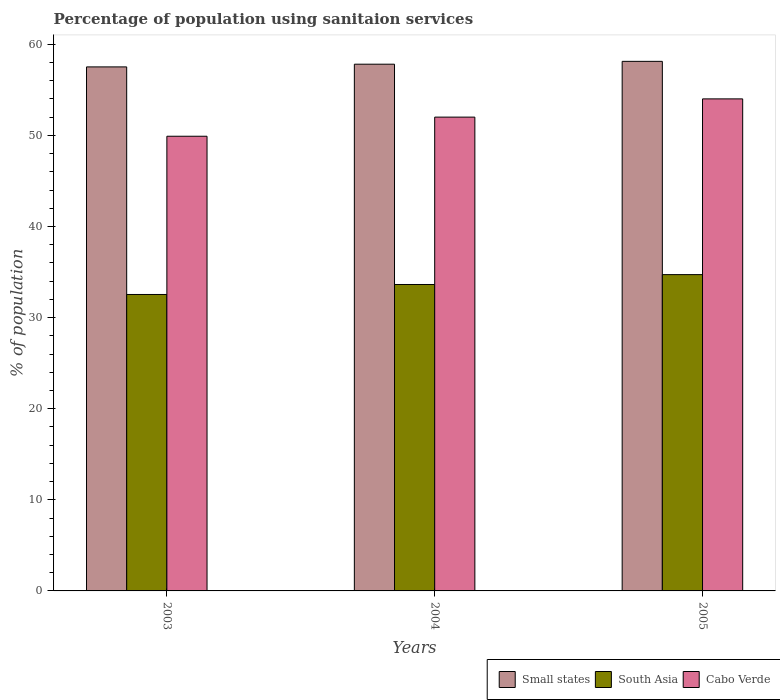How many different coloured bars are there?
Make the answer very short. 3. Are the number of bars per tick equal to the number of legend labels?
Your answer should be compact. Yes. How many bars are there on the 3rd tick from the right?
Keep it short and to the point. 3. What is the percentage of population using sanitaion services in Cabo Verde in 2005?
Provide a succinct answer. 54. Across all years, what is the maximum percentage of population using sanitaion services in South Asia?
Ensure brevity in your answer.  34.71. Across all years, what is the minimum percentage of population using sanitaion services in Small states?
Your answer should be compact. 57.51. In which year was the percentage of population using sanitaion services in South Asia maximum?
Your answer should be compact. 2005. What is the total percentage of population using sanitaion services in South Asia in the graph?
Your answer should be very brief. 100.88. What is the difference between the percentage of population using sanitaion services in South Asia in 2004 and that in 2005?
Provide a short and direct response. -1.08. What is the difference between the percentage of population using sanitaion services in Small states in 2003 and the percentage of population using sanitaion services in South Asia in 2004?
Offer a very short reply. 23.88. What is the average percentage of population using sanitaion services in South Asia per year?
Give a very brief answer. 33.63. In the year 2004, what is the difference between the percentage of population using sanitaion services in Cabo Verde and percentage of population using sanitaion services in South Asia?
Your answer should be compact. 18.37. In how many years, is the percentage of population using sanitaion services in Cabo Verde greater than 12 %?
Ensure brevity in your answer.  3. What is the ratio of the percentage of population using sanitaion services in South Asia in 2004 to that in 2005?
Keep it short and to the point. 0.97. Is the difference between the percentage of population using sanitaion services in Cabo Verde in 2004 and 2005 greater than the difference between the percentage of population using sanitaion services in South Asia in 2004 and 2005?
Keep it short and to the point. No. What is the difference between the highest and the second highest percentage of population using sanitaion services in Small states?
Keep it short and to the point. 0.31. What is the difference between the highest and the lowest percentage of population using sanitaion services in Cabo Verde?
Your response must be concise. 4.1. In how many years, is the percentage of population using sanitaion services in South Asia greater than the average percentage of population using sanitaion services in South Asia taken over all years?
Give a very brief answer. 2. What does the 3rd bar from the right in 2003 represents?
Offer a very short reply. Small states. Is it the case that in every year, the sum of the percentage of population using sanitaion services in South Asia and percentage of population using sanitaion services in Cabo Verde is greater than the percentage of population using sanitaion services in Small states?
Your response must be concise. Yes. How many bars are there?
Your answer should be compact. 9. How many years are there in the graph?
Your response must be concise. 3. What is the difference between two consecutive major ticks on the Y-axis?
Give a very brief answer. 10. Are the values on the major ticks of Y-axis written in scientific E-notation?
Offer a very short reply. No. Does the graph contain any zero values?
Your answer should be very brief. No. Where does the legend appear in the graph?
Provide a succinct answer. Bottom right. How are the legend labels stacked?
Your response must be concise. Horizontal. What is the title of the graph?
Provide a short and direct response. Percentage of population using sanitaion services. Does "Albania" appear as one of the legend labels in the graph?
Your answer should be very brief. No. What is the label or title of the X-axis?
Your answer should be compact. Years. What is the label or title of the Y-axis?
Give a very brief answer. % of population. What is the % of population in Small states in 2003?
Make the answer very short. 57.51. What is the % of population of South Asia in 2003?
Make the answer very short. 32.53. What is the % of population of Cabo Verde in 2003?
Give a very brief answer. 49.9. What is the % of population of Small states in 2004?
Your answer should be compact. 57.81. What is the % of population in South Asia in 2004?
Your answer should be very brief. 33.63. What is the % of population of Small states in 2005?
Ensure brevity in your answer.  58.12. What is the % of population of South Asia in 2005?
Your answer should be compact. 34.71. Across all years, what is the maximum % of population in Small states?
Offer a terse response. 58.12. Across all years, what is the maximum % of population of South Asia?
Provide a short and direct response. 34.71. Across all years, what is the maximum % of population in Cabo Verde?
Make the answer very short. 54. Across all years, what is the minimum % of population of Small states?
Your response must be concise. 57.51. Across all years, what is the minimum % of population of South Asia?
Give a very brief answer. 32.53. Across all years, what is the minimum % of population of Cabo Verde?
Your answer should be compact. 49.9. What is the total % of population of Small states in the graph?
Ensure brevity in your answer.  173.44. What is the total % of population of South Asia in the graph?
Your answer should be very brief. 100.88. What is the total % of population in Cabo Verde in the graph?
Your answer should be very brief. 155.9. What is the difference between the % of population of Small states in 2003 and that in 2004?
Your response must be concise. -0.3. What is the difference between the % of population in South Asia in 2003 and that in 2004?
Your answer should be compact. -1.1. What is the difference between the % of population of Small states in 2003 and that in 2005?
Make the answer very short. -0.61. What is the difference between the % of population of South Asia in 2003 and that in 2005?
Ensure brevity in your answer.  -2.18. What is the difference between the % of population in Cabo Verde in 2003 and that in 2005?
Ensure brevity in your answer.  -4.1. What is the difference between the % of population of Small states in 2004 and that in 2005?
Give a very brief answer. -0.31. What is the difference between the % of population in South Asia in 2004 and that in 2005?
Your answer should be very brief. -1.08. What is the difference between the % of population in Small states in 2003 and the % of population in South Asia in 2004?
Offer a very short reply. 23.88. What is the difference between the % of population of Small states in 2003 and the % of population of Cabo Verde in 2004?
Your response must be concise. 5.51. What is the difference between the % of population of South Asia in 2003 and the % of population of Cabo Verde in 2004?
Your answer should be compact. -19.47. What is the difference between the % of population in Small states in 2003 and the % of population in South Asia in 2005?
Provide a succinct answer. 22.8. What is the difference between the % of population of Small states in 2003 and the % of population of Cabo Verde in 2005?
Provide a short and direct response. 3.51. What is the difference between the % of population in South Asia in 2003 and the % of population in Cabo Verde in 2005?
Your response must be concise. -21.47. What is the difference between the % of population of Small states in 2004 and the % of population of South Asia in 2005?
Your answer should be very brief. 23.09. What is the difference between the % of population of Small states in 2004 and the % of population of Cabo Verde in 2005?
Make the answer very short. 3.81. What is the difference between the % of population of South Asia in 2004 and the % of population of Cabo Verde in 2005?
Offer a terse response. -20.37. What is the average % of population of Small states per year?
Offer a very short reply. 57.81. What is the average % of population of South Asia per year?
Your response must be concise. 33.63. What is the average % of population of Cabo Verde per year?
Your answer should be very brief. 51.97. In the year 2003, what is the difference between the % of population in Small states and % of population in South Asia?
Offer a very short reply. 24.98. In the year 2003, what is the difference between the % of population of Small states and % of population of Cabo Verde?
Provide a succinct answer. 7.61. In the year 2003, what is the difference between the % of population of South Asia and % of population of Cabo Verde?
Make the answer very short. -17.37. In the year 2004, what is the difference between the % of population in Small states and % of population in South Asia?
Make the answer very short. 24.18. In the year 2004, what is the difference between the % of population of Small states and % of population of Cabo Verde?
Ensure brevity in your answer.  5.81. In the year 2004, what is the difference between the % of population of South Asia and % of population of Cabo Verde?
Ensure brevity in your answer.  -18.37. In the year 2005, what is the difference between the % of population of Small states and % of population of South Asia?
Provide a short and direct response. 23.41. In the year 2005, what is the difference between the % of population in Small states and % of population in Cabo Verde?
Your response must be concise. 4.12. In the year 2005, what is the difference between the % of population of South Asia and % of population of Cabo Verde?
Your response must be concise. -19.29. What is the ratio of the % of population of South Asia in 2003 to that in 2004?
Your answer should be compact. 0.97. What is the ratio of the % of population of Cabo Verde in 2003 to that in 2004?
Give a very brief answer. 0.96. What is the ratio of the % of population in South Asia in 2003 to that in 2005?
Keep it short and to the point. 0.94. What is the ratio of the % of population of Cabo Verde in 2003 to that in 2005?
Make the answer very short. 0.92. What is the ratio of the % of population in Small states in 2004 to that in 2005?
Give a very brief answer. 0.99. What is the ratio of the % of population in South Asia in 2004 to that in 2005?
Provide a succinct answer. 0.97. What is the ratio of the % of population in Cabo Verde in 2004 to that in 2005?
Keep it short and to the point. 0.96. What is the difference between the highest and the second highest % of population in Small states?
Offer a very short reply. 0.31. What is the difference between the highest and the second highest % of population in South Asia?
Offer a terse response. 1.08. What is the difference between the highest and the lowest % of population of Small states?
Provide a succinct answer. 0.61. What is the difference between the highest and the lowest % of population in South Asia?
Your answer should be compact. 2.18. 